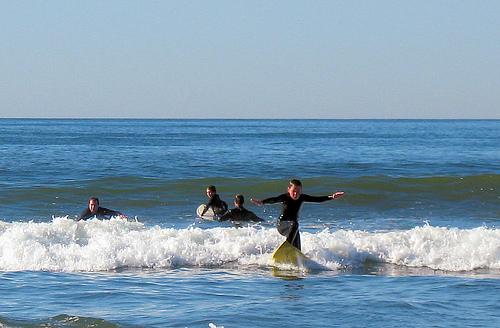How many people are wearing black?
Keep it brief. 4. What is the weather like in this scene?
Be succinct. Sunny. Are these people surfing?
Concise answer only. Yes. 